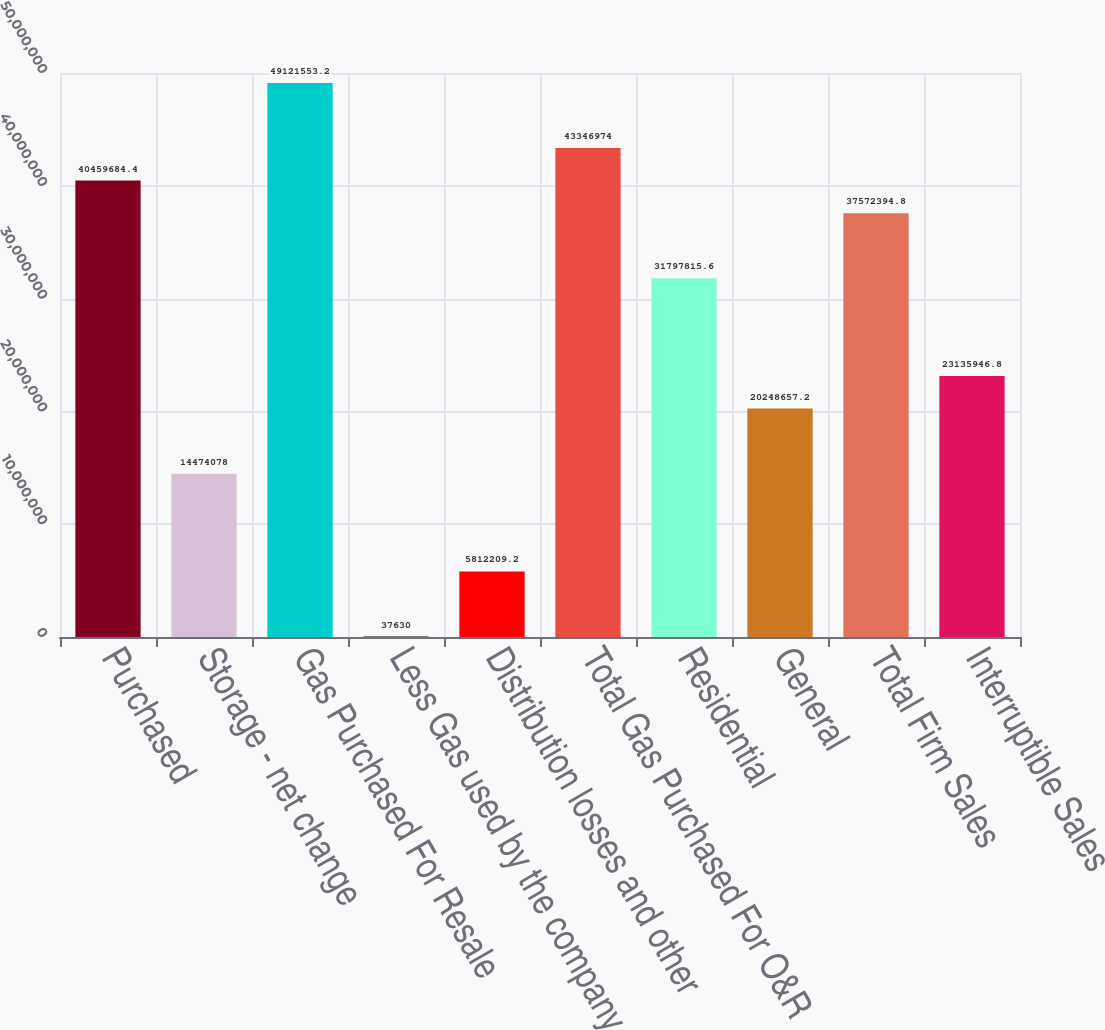Convert chart. <chart><loc_0><loc_0><loc_500><loc_500><bar_chart><fcel>Purchased<fcel>Storage - net change<fcel>Gas Purchased For Resale<fcel>Less Gas used by the company<fcel>Distribution losses and other<fcel>Total Gas Purchased For O&R<fcel>Residential<fcel>General<fcel>Total Firm Sales<fcel>Interruptible Sales<nl><fcel>4.04597e+07<fcel>1.44741e+07<fcel>4.91216e+07<fcel>37630<fcel>5.81221e+06<fcel>4.3347e+07<fcel>3.17978e+07<fcel>2.02487e+07<fcel>3.75724e+07<fcel>2.31359e+07<nl></chart> 